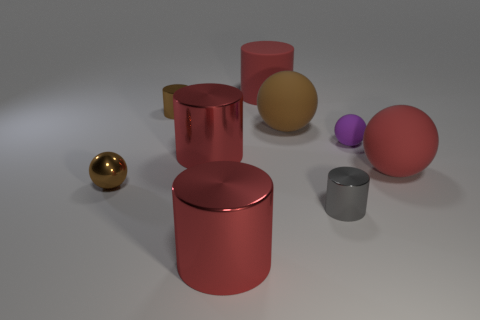Subtract all red cylinders. How many were subtracted if there are1red cylinders left? 2 Subtract all green balls. How many red cylinders are left? 3 Subtract all small brown cylinders. How many cylinders are left? 4 Subtract all brown cylinders. How many cylinders are left? 4 Subtract all green cylinders. Subtract all purple balls. How many cylinders are left? 5 Subtract all cylinders. How many objects are left? 4 Subtract all large metallic cylinders. Subtract all tiny brown balls. How many objects are left? 6 Add 8 purple spheres. How many purple spheres are left? 9 Add 3 large matte cylinders. How many large matte cylinders exist? 4 Subtract 1 red balls. How many objects are left? 8 